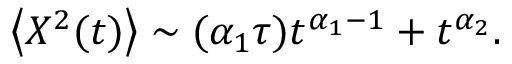<formula> <loc_0><loc_0><loc_500><loc_500>\left < X ^ { 2 } ( t ) \right > \sim ( \alpha _ { 1 } \tau ) t ^ { \alpha _ { 1 } - 1 } + t ^ { \alpha _ { 2 } } .</formula> 